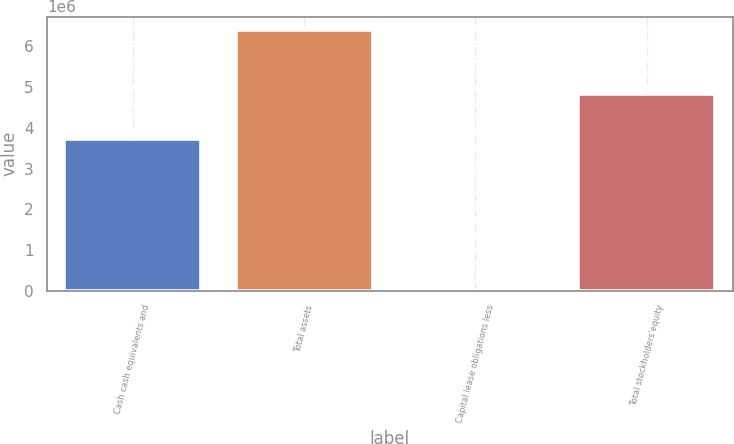Convert chart to OTSL. <chart><loc_0><loc_0><loc_500><loc_500><bar_chart><fcel>Cash cash equivalents and<fcel>Total assets<fcel>Capital lease obligations less<fcel>Total stockholders'equity<nl><fcel>3.72788e+06<fcel>6.41224e+06<fcel>18998<fcel>4.8277e+06<nl></chart> 